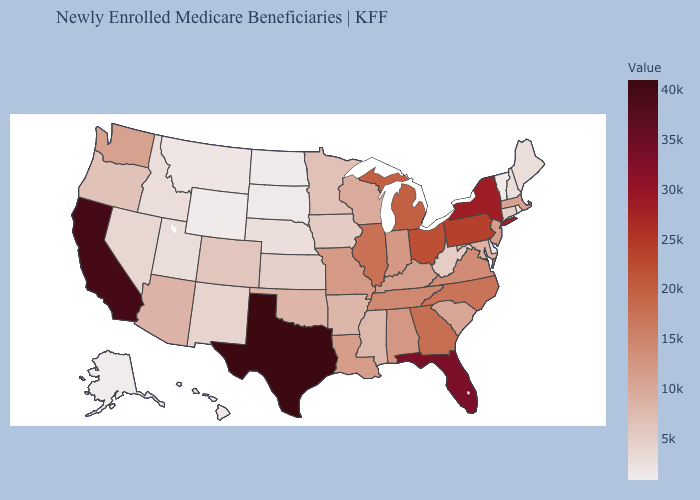Among the states that border Louisiana , does Mississippi have the lowest value?
Concise answer only. Yes. Which states have the highest value in the USA?
Answer briefly. Texas. Which states have the lowest value in the USA?
Concise answer only. Alaska. Is the legend a continuous bar?
Be succinct. Yes. Does Colorado have the lowest value in the USA?
Give a very brief answer. No. Does Alaska have the lowest value in the USA?
Keep it brief. Yes. Does Florida have a lower value than New Mexico?
Quick response, please. No. 